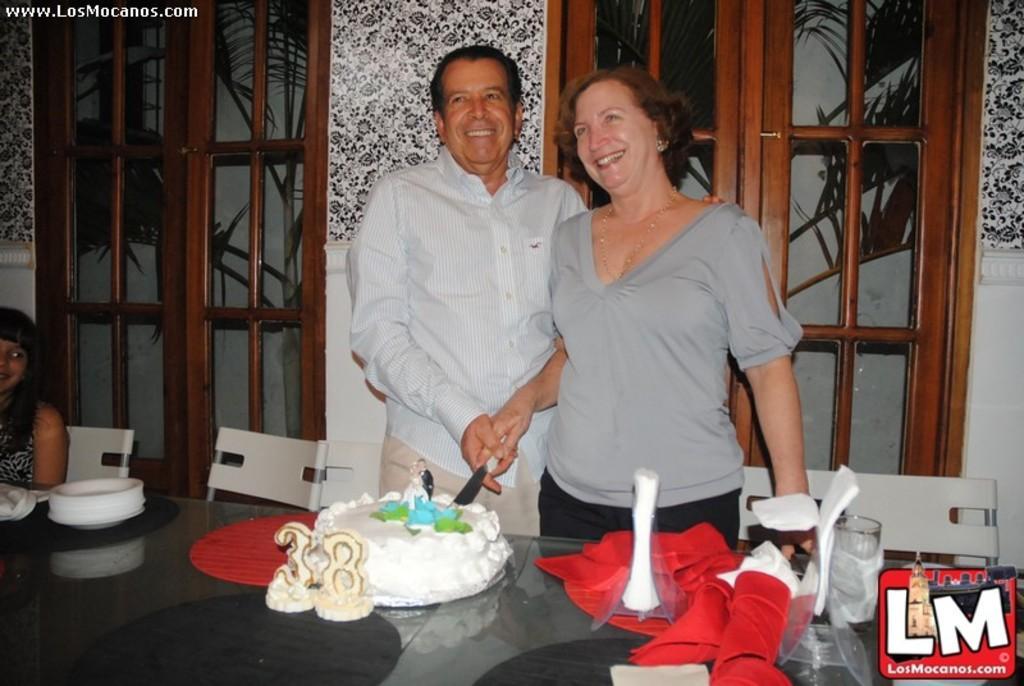Please provide a concise description of this image. In the foreground two persons are standing and cutting a cake with knife. In the left middle a woman is sitting on the chair in front of the table on which cake, plates, mat, glasses and so on kept. At the bottom right a logo is there. In the background windows are visible and doors are visible, through which plants are visible and a wall of white and black in color is visible. This image is taken inside a house. 